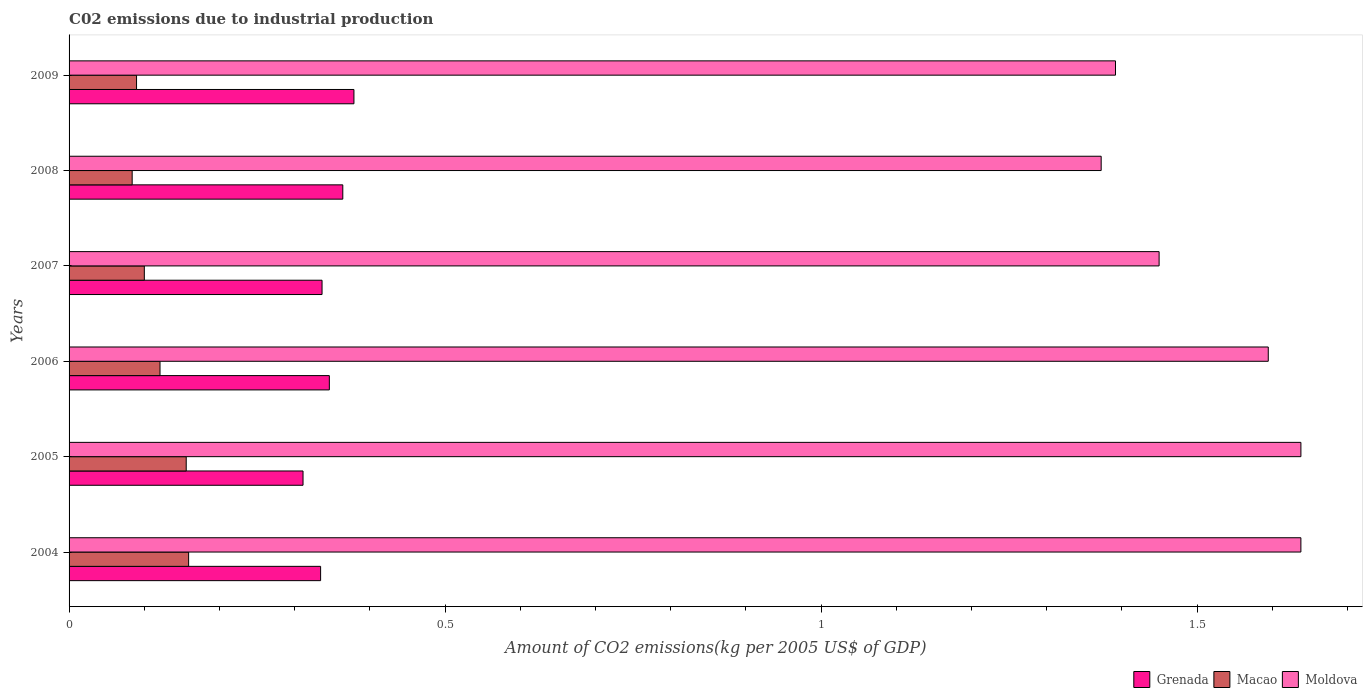How many groups of bars are there?
Your answer should be compact. 6. Are the number of bars on each tick of the Y-axis equal?
Provide a short and direct response. Yes. How many bars are there on the 5th tick from the top?
Offer a terse response. 3. How many bars are there on the 3rd tick from the bottom?
Offer a very short reply. 3. What is the label of the 4th group of bars from the top?
Provide a succinct answer. 2006. What is the amount of CO2 emitted due to industrial production in Moldova in 2005?
Keep it short and to the point. 1.64. Across all years, what is the maximum amount of CO2 emitted due to industrial production in Grenada?
Your answer should be very brief. 0.38. Across all years, what is the minimum amount of CO2 emitted due to industrial production in Macao?
Make the answer very short. 0.08. In which year was the amount of CO2 emitted due to industrial production in Moldova maximum?
Your answer should be very brief. 2005. What is the total amount of CO2 emitted due to industrial production in Grenada in the graph?
Your answer should be compact. 2.07. What is the difference between the amount of CO2 emitted due to industrial production in Moldova in 2007 and that in 2009?
Provide a short and direct response. 0.06. What is the difference between the amount of CO2 emitted due to industrial production in Macao in 2006 and the amount of CO2 emitted due to industrial production in Grenada in 2007?
Your answer should be very brief. -0.22. What is the average amount of CO2 emitted due to industrial production in Macao per year?
Provide a succinct answer. 0.12. In the year 2007, what is the difference between the amount of CO2 emitted due to industrial production in Macao and amount of CO2 emitted due to industrial production in Grenada?
Offer a very short reply. -0.24. What is the ratio of the amount of CO2 emitted due to industrial production in Macao in 2005 to that in 2007?
Your answer should be compact. 1.56. Is the difference between the amount of CO2 emitted due to industrial production in Macao in 2007 and 2009 greater than the difference between the amount of CO2 emitted due to industrial production in Grenada in 2007 and 2009?
Your answer should be very brief. Yes. What is the difference between the highest and the second highest amount of CO2 emitted due to industrial production in Macao?
Make the answer very short. 0. What is the difference between the highest and the lowest amount of CO2 emitted due to industrial production in Macao?
Offer a terse response. 0.08. What does the 3rd bar from the top in 2009 represents?
Your response must be concise. Grenada. What does the 3rd bar from the bottom in 2004 represents?
Make the answer very short. Moldova. How many bars are there?
Make the answer very short. 18. Are all the bars in the graph horizontal?
Keep it short and to the point. Yes. How many years are there in the graph?
Your answer should be compact. 6. Are the values on the major ticks of X-axis written in scientific E-notation?
Your answer should be very brief. No. Does the graph contain any zero values?
Ensure brevity in your answer.  No. Does the graph contain grids?
Your answer should be very brief. No. How many legend labels are there?
Give a very brief answer. 3. What is the title of the graph?
Keep it short and to the point. C02 emissions due to industrial production. What is the label or title of the X-axis?
Your answer should be very brief. Amount of CO2 emissions(kg per 2005 US$ of GDP). What is the label or title of the Y-axis?
Offer a terse response. Years. What is the Amount of CO2 emissions(kg per 2005 US$ of GDP) of Grenada in 2004?
Provide a short and direct response. 0.33. What is the Amount of CO2 emissions(kg per 2005 US$ of GDP) of Macao in 2004?
Give a very brief answer. 0.16. What is the Amount of CO2 emissions(kg per 2005 US$ of GDP) in Moldova in 2004?
Ensure brevity in your answer.  1.64. What is the Amount of CO2 emissions(kg per 2005 US$ of GDP) of Grenada in 2005?
Provide a short and direct response. 0.31. What is the Amount of CO2 emissions(kg per 2005 US$ of GDP) of Macao in 2005?
Provide a succinct answer. 0.16. What is the Amount of CO2 emissions(kg per 2005 US$ of GDP) of Moldova in 2005?
Make the answer very short. 1.64. What is the Amount of CO2 emissions(kg per 2005 US$ of GDP) of Grenada in 2006?
Offer a very short reply. 0.35. What is the Amount of CO2 emissions(kg per 2005 US$ of GDP) in Macao in 2006?
Provide a short and direct response. 0.12. What is the Amount of CO2 emissions(kg per 2005 US$ of GDP) of Moldova in 2006?
Your answer should be very brief. 1.59. What is the Amount of CO2 emissions(kg per 2005 US$ of GDP) of Grenada in 2007?
Provide a succinct answer. 0.34. What is the Amount of CO2 emissions(kg per 2005 US$ of GDP) in Macao in 2007?
Offer a very short reply. 0.1. What is the Amount of CO2 emissions(kg per 2005 US$ of GDP) in Moldova in 2007?
Offer a terse response. 1.45. What is the Amount of CO2 emissions(kg per 2005 US$ of GDP) of Grenada in 2008?
Your answer should be compact. 0.36. What is the Amount of CO2 emissions(kg per 2005 US$ of GDP) of Macao in 2008?
Offer a terse response. 0.08. What is the Amount of CO2 emissions(kg per 2005 US$ of GDP) of Moldova in 2008?
Provide a short and direct response. 1.37. What is the Amount of CO2 emissions(kg per 2005 US$ of GDP) in Grenada in 2009?
Provide a short and direct response. 0.38. What is the Amount of CO2 emissions(kg per 2005 US$ of GDP) of Macao in 2009?
Keep it short and to the point. 0.09. What is the Amount of CO2 emissions(kg per 2005 US$ of GDP) of Moldova in 2009?
Ensure brevity in your answer.  1.39. Across all years, what is the maximum Amount of CO2 emissions(kg per 2005 US$ of GDP) of Grenada?
Your response must be concise. 0.38. Across all years, what is the maximum Amount of CO2 emissions(kg per 2005 US$ of GDP) in Macao?
Offer a very short reply. 0.16. Across all years, what is the maximum Amount of CO2 emissions(kg per 2005 US$ of GDP) of Moldova?
Make the answer very short. 1.64. Across all years, what is the minimum Amount of CO2 emissions(kg per 2005 US$ of GDP) in Grenada?
Give a very brief answer. 0.31. Across all years, what is the minimum Amount of CO2 emissions(kg per 2005 US$ of GDP) of Macao?
Give a very brief answer. 0.08. Across all years, what is the minimum Amount of CO2 emissions(kg per 2005 US$ of GDP) in Moldova?
Give a very brief answer. 1.37. What is the total Amount of CO2 emissions(kg per 2005 US$ of GDP) of Grenada in the graph?
Offer a terse response. 2.07. What is the total Amount of CO2 emissions(kg per 2005 US$ of GDP) in Macao in the graph?
Give a very brief answer. 0.71. What is the total Amount of CO2 emissions(kg per 2005 US$ of GDP) of Moldova in the graph?
Your response must be concise. 9.09. What is the difference between the Amount of CO2 emissions(kg per 2005 US$ of GDP) in Grenada in 2004 and that in 2005?
Your response must be concise. 0.02. What is the difference between the Amount of CO2 emissions(kg per 2005 US$ of GDP) of Macao in 2004 and that in 2005?
Your answer should be compact. 0. What is the difference between the Amount of CO2 emissions(kg per 2005 US$ of GDP) of Grenada in 2004 and that in 2006?
Provide a short and direct response. -0.01. What is the difference between the Amount of CO2 emissions(kg per 2005 US$ of GDP) in Macao in 2004 and that in 2006?
Your answer should be compact. 0.04. What is the difference between the Amount of CO2 emissions(kg per 2005 US$ of GDP) in Moldova in 2004 and that in 2006?
Your answer should be compact. 0.04. What is the difference between the Amount of CO2 emissions(kg per 2005 US$ of GDP) of Grenada in 2004 and that in 2007?
Provide a succinct answer. -0. What is the difference between the Amount of CO2 emissions(kg per 2005 US$ of GDP) in Macao in 2004 and that in 2007?
Give a very brief answer. 0.06. What is the difference between the Amount of CO2 emissions(kg per 2005 US$ of GDP) in Moldova in 2004 and that in 2007?
Your answer should be compact. 0.19. What is the difference between the Amount of CO2 emissions(kg per 2005 US$ of GDP) in Grenada in 2004 and that in 2008?
Give a very brief answer. -0.03. What is the difference between the Amount of CO2 emissions(kg per 2005 US$ of GDP) in Macao in 2004 and that in 2008?
Ensure brevity in your answer.  0.08. What is the difference between the Amount of CO2 emissions(kg per 2005 US$ of GDP) of Moldova in 2004 and that in 2008?
Offer a terse response. 0.27. What is the difference between the Amount of CO2 emissions(kg per 2005 US$ of GDP) in Grenada in 2004 and that in 2009?
Provide a short and direct response. -0.04. What is the difference between the Amount of CO2 emissions(kg per 2005 US$ of GDP) of Macao in 2004 and that in 2009?
Offer a terse response. 0.07. What is the difference between the Amount of CO2 emissions(kg per 2005 US$ of GDP) of Moldova in 2004 and that in 2009?
Give a very brief answer. 0.25. What is the difference between the Amount of CO2 emissions(kg per 2005 US$ of GDP) in Grenada in 2005 and that in 2006?
Your answer should be compact. -0.04. What is the difference between the Amount of CO2 emissions(kg per 2005 US$ of GDP) in Macao in 2005 and that in 2006?
Provide a succinct answer. 0.03. What is the difference between the Amount of CO2 emissions(kg per 2005 US$ of GDP) of Moldova in 2005 and that in 2006?
Your response must be concise. 0.04. What is the difference between the Amount of CO2 emissions(kg per 2005 US$ of GDP) in Grenada in 2005 and that in 2007?
Ensure brevity in your answer.  -0.03. What is the difference between the Amount of CO2 emissions(kg per 2005 US$ of GDP) of Macao in 2005 and that in 2007?
Your response must be concise. 0.06. What is the difference between the Amount of CO2 emissions(kg per 2005 US$ of GDP) of Moldova in 2005 and that in 2007?
Keep it short and to the point. 0.19. What is the difference between the Amount of CO2 emissions(kg per 2005 US$ of GDP) of Grenada in 2005 and that in 2008?
Provide a short and direct response. -0.05. What is the difference between the Amount of CO2 emissions(kg per 2005 US$ of GDP) in Macao in 2005 and that in 2008?
Provide a short and direct response. 0.07. What is the difference between the Amount of CO2 emissions(kg per 2005 US$ of GDP) of Moldova in 2005 and that in 2008?
Offer a very short reply. 0.27. What is the difference between the Amount of CO2 emissions(kg per 2005 US$ of GDP) of Grenada in 2005 and that in 2009?
Give a very brief answer. -0.07. What is the difference between the Amount of CO2 emissions(kg per 2005 US$ of GDP) in Macao in 2005 and that in 2009?
Keep it short and to the point. 0.07. What is the difference between the Amount of CO2 emissions(kg per 2005 US$ of GDP) of Moldova in 2005 and that in 2009?
Make the answer very short. 0.25. What is the difference between the Amount of CO2 emissions(kg per 2005 US$ of GDP) of Grenada in 2006 and that in 2007?
Give a very brief answer. 0.01. What is the difference between the Amount of CO2 emissions(kg per 2005 US$ of GDP) in Macao in 2006 and that in 2007?
Provide a succinct answer. 0.02. What is the difference between the Amount of CO2 emissions(kg per 2005 US$ of GDP) of Moldova in 2006 and that in 2007?
Ensure brevity in your answer.  0.15. What is the difference between the Amount of CO2 emissions(kg per 2005 US$ of GDP) of Grenada in 2006 and that in 2008?
Keep it short and to the point. -0.02. What is the difference between the Amount of CO2 emissions(kg per 2005 US$ of GDP) in Macao in 2006 and that in 2008?
Ensure brevity in your answer.  0.04. What is the difference between the Amount of CO2 emissions(kg per 2005 US$ of GDP) of Moldova in 2006 and that in 2008?
Give a very brief answer. 0.22. What is the difference between the Amount of CO2 emissions(kg per 2005 US$ of GDP) of Grenada in 2006 and that in 2009?
Make the answer very short. -0.03. What is the difference between the Amount of CO2 emissions(kg per 2005 US$ of GDP) in Macao in 2006 and that in 2009?
Keep it short and to the point. 0.03. What is the difference between the Amount of CO2 emissions(kg per 2005 US$ of GDP) of Moldova in 2006 and that in 2009?
Keep it short and to the point. 0.2. What is the difference between the Amount of CO2 emissions(kg per 2005 US$ of GDP) in Grenada in 2007 and that in 2008?
Offer a terse response. -0.03. What is the difference between the Amount of CO2 emissions(kg per 2005 US$ of GDP) in Macao in 2007 and that in 2008?
Your response must be concise. 0.02. What is the difference between the Amount of CO2 emissions(kg per 2005 US$ of GDP) of Moldova in 2007 and that in 2008?
Offer a very short reply. 0.08. What is the difference between the Amount of CO2 emissions(kg per 2005 US$ of GDP) in Grenada in 2007 and that in 2009?
Your answer should be compact. -0.04. What is the difference between the Amount of CO2 emissions(kg per 2005 US$ of GDP) in Macao in 2007 and that in 2009?
Your answer should be compact. 0.01. What is the difference between the Amount of CO2 emissions(kg per 2005 US$ of GDP) in Moldova in 2007 and that in 2009?
Your answer should be compact. 0.06. What is the difference between the Amount of CO2 emissions(kg per 2005 US$ of GDP) in Grenada in 2008 and that in 2009?
Offer a very short reply. -0.01. What is the difference between the Amount of CO2 emissions(kg per 2005 US$ of GDP) in Macao in 2008 and that in 2009?
Keep it short and to the point. -0.01. What is the difference between the Amount of CO2 emissions(kg per 2005 US$ of GDP) in Moldova in 2008 and that in 2009?
Offer a terse response. -0.02. What is the difference between the Amount of CO2 emissions(kg per 2005 US$ of GDP) of Grenada in 2004 and the Amount of CO2 emissions(kg per 2005 US$ of GDP) of Macao in 2005?
Your answer should be compact. 0.18. What is the difference between the Amount of CO2 emissions(kg per 2005 US$ of GDP) in Grenada in 2004 and the Amount of CO2 emissions(kg per 2005 US$ of GDP) in Moldova in 2005?
Your answer should be very brief. -1.3. What is the difference between the Amount of CO2 emissions(kg per 2005 US$ of GDP) of Macao in 2004 and the Amount of CO2 emissions(kg per 2005 US$ of GDP) of Moldova in 2005?
Keep it short and to the point. -1.48. What is the difference between the Amount of CO2 emissions(kg per 2005 US$ of GDP) in Grenada in 2004 and the Amount of CO2 emissions(kg per 2005 US$ of GDP) in Macao in 2006?
Your response must be concise. 0.21. What is the difference between the Amount of CO2 emissions(kg per 2005 US$ of GDP) of Grenada in 2004 and the Amount of CO2 emissions(kg per 2005 US$ of GDP) of Moldova in 2006?
Your answer should be very brief. -1.26. What is the difference between the Amount of CO2 emissions(kg per 2005 US$ of GDP) in Macao in 2004 and the Amount of CO2 emissions(kg per 2005 US$ of GDP) in Moldova in 2006?
Give a very brief answer. -1.44. What is the difference between the Amount of CO2 emissions(kg per 2005 US$ of GDP) of Grenada in 2004 and the Amount of CO2 emissions(kg per 2005 US$ of GDP) of Macao in 2007?
Your answer should be very brief. 0.23. What is the difference between the Amount of CO2 emissions(kg per 2005 US$ of GDP) in Grenada in 2004 and the Amount of CO2 emissions(kg per 2005 US$ of GDP) in Moldova in 2007?
Provide a succinct answer. -1.12. What is the difference between the Amount of CO2 emissions(kg per 2005 US$ of GDP) in Macao in 2004 and the Amount of CO2 emissions(kg per 2005 US$ of GDP) in Moldova in 2007?
Your response must be concise. -1.29. What is the difference between the Amount of CO2 emissions(kg per 2005 US$ of GDP) of Grenada in 2004 and the Amount of CO2 emissions(kg per 2005 US$ of GDP) of Macao in 2008?
Your response must be concise. 0.25. What is the difference between the Amount of CO2 emissions(kg per 2005 US$ of GDP) of Grenada in 2004 and the Amount of CO2 emissions(kg per 2005 US$ of GDP) of Moldova in 2008?
Give a very brief answer. -1.04. What is the difference between the Amount of CO2 emissions(kg per 2005 US$ of GDP) of Macao in 2004 and the Amount of CO2 emissions(kg per 2005 US$ of GDP) of Moldova in 2008?
Provide a succinct answer. -1.21. What is the difference between the Amount of CO2 emissions(kg per 2005 US$ of GDP) in Grenada in 2004 and the Amount of CO2 emissions(kg per 2005 US$ of GDP) in Macao in 2009?
Provide a short and direct response. 0.24. What is the difference between the Amount of CO2 emissions(kg per 2005 US$ of GDP) in Grenada in 2004 and the Amount of CO2 emissions(kg per 2005 US$ of GDP) in Moldova in 2009?
Ensure brevity in your answer.  -1.06. What is the difference between the Amount of CO2 emissions(kg per 2005 US$ of GDP) in Macao in 2004 and the Amount of CO2 emissions(kg per 2005 US$ of GDP) in Moldova in 2009?
Provide a succinct answer. -1.23. What is the difference between the Amount of CO2 emissions(kg per 2005 US$ of GDP) of Grenada in 2005 and the Amount of CO2 emissions(kg per 2005 US$ of GDP) of Macao in 2006?
Give a very brief answer. 0.19. What is the difference between the Amount of CO2 emissions(kg per 2005 US$ of GDP) of Grenada in 2005 and the Amount of CO2 emissions(kg per 2005 US$ of GDP) of Moldova in 2006?
Offer a very short reply. -1.28. What is the difference between the Amount of CO2 emissions(kg per 2005 US$ of GDP) of Macao in 2005 and the Amount of CO2 emissions(kg per 2005 US$ of GDP) of Moldova in 2006?
Make the answer very short. -1.44. What is the difference between the Amount of CO2 emissions(kg per 2005 US$ of GDP) of Grenada in 2005 and the Amount of CO2 emissions(kg per 2005 US$ of GDP) of Macao in 2007?
Make the answer very short. 0.21. What is the difference between the Amount of CO2 emissions(kg per 2005 US$ of GDP) of Grenada in 2005 and the Amount of CO2 emissions(kg per 2005 US$ of GDP) of Moldova in 2007?
Give a very brief answer. -1.14. What is the difference between the Amount of CO2 emissions(kg per 2005 US$ of GDP) in Macao in 2005 and the Amount of CO2 emissions(kg per 2005 US$ of GDP) in Moldova in 2007?
Make the answer very short. -1.29. What is the difference between the Amount of CO2 emissions(kg per 2005 US$ of GDP) of Grenada in 2005 and the Amount of CO2 emissions(kg per 2005 US$ of GDP) of Macao in 2008?
Provide a short and direct response. 0.23. What is the difference between the Amount of CO2 emissions(kg per 2005 US$ of GDP) in Grenada in 2005 and the Amount of CO2 emissions(kg per 2005 US$ of GDP) in Moldova in 2008?
Make the answer very short. -1.06. What is the difference between the Amount of CO2 emissions(kg per 2005 US$ of GDP) of Macao in 2005 and the Amount of CO2 emissions(kg per 2005 US$ of GDP) of Moldova in 2008?
Provide a short and direct response. -1.22. What is the difference between the Amount of CO2 emissions(kg per 2005 US$ of GDP) of Grenada in 2005 and the Amount of CO2 emissions(kg per 2005 US$ of GDP) of Macao in 2009?
Provide a succinct answer. 0.22. What is the difference between the Amount of CO2 emissions(kg per 2005 US$ of GDP) in Grenada in 2005 and the Amount of CO2 emissions(kg per 2005 US$ of GDP) in Moldova in 2009?
Give a very brief answer. -1.08. What is the difference between the Amount of CO2 emissions(kg per 2005 US$ of GDP) of Macao in 2005 and the Amount of CO2 emissions(kg per 2005 US$ of GDP) of Moldova in 2009?
Your answer should be very brief. -1.24. What is the difference between the Amount of CO2 emissions(kg per 2005 US$ of GDP) in Grenada in 2006 and the Amount of CO2 emissions(kg per 2005 US$ of GDP) in Macao in 2007?
Provide a succinct answer. 0.25. What is the difference between the Amount of CO2 emissions(kg per 2005 US$ of GDP) of Grenada in 2006 and the Amount of CO2 emissions(kg per 2005 US$ of GDP) of Moldova in 2007?
Your answer should be very brief. -1.1. What is the difference between the Amount of CO2 emissions(kg per 2005 US$ of GDP) in Macao in 2006 and the Amount of CO2 emissions(kg per 2005 US$ of GDP) in Moldova in 2007?
Your answer should be very brief. -1.33. What is the difference between the Amount of CO2 emissions(kg per 2005 US$ of GDP) of Grenada in 2006 and the Amount of CO2 emissions(kg per 2005 US$ of GDP) of Macao in 2008?
Provide a succinct answer. 0.26. What is the difference between the Amount of CO2 emissions(kg per 2005 US$ of GDP) of Grenada in 2006 and the Amount of CO2 emissions(kg per 2005 US$ of GDP) of Moldova in 2008?
Your response must be concise. -1.03. What is the difference between the Amount of CO2 emissions(kg per 2005 US$ of GDP) of Macao in 2006 and the Amount of CO2 emissions(kg per 2005 US$ of GDP) of Moldova in 2008?
Make the answer very short. -1.25. What is the difference between the Amount of CO2 emissions(kg per 2005 US$ of GDP) in Grenada in 2006 and the Amount of CO2 emissions(kg per 2005 US$ of GDP) in Macao in 2009?
Offer a very short reply. 0.26. What is the difference between the Amount of CO2 emissions(kg per 2005 US$ of GDP) in Grenada in 2006 and the Amount of CO2 emissions(kg per 2005 US$ of GDP) in Moldova in 2009?
Your answer should be compact. -1.05. What is the difference between the Amount of CO2 emissions(kg per 2005 US$ of GDP) of Macao in 2006 and the Amount of CO2 emissions(kg per 2005 US$ of GDP) of Moldova in 2009?
Keep it short and to the point. -1.27. What is the difference between the Amount of CO2 emissions(kg per 2005 US$ of GDP) of Grenada in 2007 and the Amount of CO2 emissions(kg per 2005 US$ of GDP) of Macao in 2008?
Provide a short and direct response. 0.25. What is the difference between the Amount of CO2 emissions(kg per 2005 US$ of GDP) in Grenada in 2007 and the Amount of CO2 emissions(kg per 2005 US$ of GDP) in Moldova in 2008?
Ensure brevity in your answer.  -1.04. What is the difference between the Amount of CO2 emissions(kg per 2005 US$ of GDP) in Macao in 2007 and the Amount of CO2 emissions(kg per 2005 US$ of GDP) in Moldova in 2008?
Offer a terse response. -1.27. What is the difference between the Amount of CO2 emissions(kg per 2005 US$ of GDP) in Grenada in 2007 and the Amount of CO2 emissions(kg per 2005 US$ of GDP) in Macao in 2009?
Offer a terse response. 0.25. What is the difference between the Amount of CO2 emissions(kg per 2005 US$ of GDP) of Grenada in 2007 and the Amount of CO2 emissions(kg per 2005 US$ of GDP) of Moldova in 2009?
Offer a very short reply. -1.06. What is the difference between the Amount of CO2 emissions(kg per 2005 US$ of GDP) of Macao in 2007 and the Amount of CO2 emissions(kg per 2005 US$ of GDP) of Moldova in 2009?
Your answer should be compact. -1.29. What is the difference between the Amount of CO2 emissions(kg per 2005 US$ of GDP) of Grenada in 2008 and the Amount of CO2 emissions(kg per 2005 US$ of GDP) of Macao in 2009?
Your answer should be very brief. 0.27. What is the difference between the Amount of CO2 emissions(kg per 2005 US$ of GDP) in Grenada in 2008 and the Amount of CO2 emissions(kg per 2005 US$ of GDP) in Moldova in 2009?
Provide a succinct answer. -1.03. What is the difference between the Amount of CO2 emissions(kg per 2005 US$ of GDP) in Macao in 2008 and the Amount of CO2 emissions(kg per 2005 US$ of GDP) in Moldova in 2009?
Give a very brief answer. -1.31. What is the average Amount of CO2 emissions(kg per 2005 US$ of GDP) in Grenada per year?
Your response must be concise. 0.35. What is the average Amount of CO2 emissions(kg per 2005 US$ of GDP) of Macao per year?
Your answer should be very brief. 0.12. What is the average Amount of CO2 emissions(kg per 2005 US$ of GDP) in Moldova per year?
Your response must be concise. 1.51. In the year 2004, what is the difference between the Amount of CO2 emissions(kg per 2005 US$ of GDP) of Grenada and Amount of CO2 emissions(kg per 2005 US$ of GDP) of Macao?
Your response must be concise. 0.18. In the year 2004, what is the difference between the Amount of CO2 emissions(kg per 2005 US$ of GDP) of Grenada and Amount of CO2 emissions(kg per 2005 US$ of GDP) of Moldova?
Offer a terse response. -1.3. In the year 2004, what is the difference between the Amount of CO2 emissions(kg per 2005 US$ of GDP) in Macao and Amount of CO2 emissions(kg per 2005 US$ of GDP) in Moldova?
Provide a succinct answer. -1.48. In the year 2005, what is the difference between the Amount of CO2 emissions(kg per 2005 US$ of GDP) of Grenada and Amount of CO2 emissions(kg per 2005 US$ of GDP) of Macao?
Provide a short and direct response. 0.16. In the year 2005, what is the difference between the Amount of CO2 emissions(kg per 2005 US$ of GDP) of Grenada and Amount of CO2 emissions(kg per 2005 US$ of GDP) of Moldova?
Offer a very short reply. -1.33. In the year 2005, what is the difference between the Amount of CO2 emissions(kg per 2005 US$ of GDP) of Macao and Amount of CO2 emissions(kg per 2005 US$ of GDP) of Moldova?
Provide a succinct answer. -1.48. In the year 2006, what is the difference between the Amount of CO2 emissions(kg per 2005 US$ of GDP) of Grenada and Amount of CO2 emissions(kg per 2005 US$ of GDP) of Macao?
Your answer should be very brief. 0.23. In the year 2006, what is the difference between the Amount of CO2 emissions(kg per 2005 US$ of GDP) of Grenada and Amount of CO2 emissions(kg per 2005 US$ of GDP) of Moldova?
Your answer should be very brief. -1.25. In the year 2006, what is the difference between the Amount of CO2 emissions(kg per 2005 US$ of GDP) of Macao and Amount of CO2 emissions(kg per 2005 US$ of GDP) of Moldova?
Offer a terse response. -1.47. In the year 2007, what is the difference between the Amount of CO2 emissions(kg per 2005 US$ of GDP) in Grenada and Amount of CO2 emissions(kg per 2005 US$ of GDP) in Macao?
Your answer should be compact. 0.24. In the year 2007, what is the difference between the Amount of CO2 emissions(kg per 2005 US$ of GDP) in Grenada and Amount of CO2 emissions(kg per 2005 US$ of GDP) in Moldova?
Provide a succinct answer. -1.11. In the year 2007, what is the difference between the Amount of CO2 emissions(kg per 2005 US$ of GDP) in Macao and Amount of CO2 emissions(kg per 2005 US$ of GDP) in Moldova?
Keep it short and to the point. -1.35. In the year 2008, what is the difference between the Amount of CO2 emissions(kg per 2005 US$ of GDP) in Grenada and Amount of CO2 emissions(kg per 2005 US$ of GDP) in Macao?
Make the answer very short. 0.28. In the year 2008, what is the difference between the Amount of CO2 emissions(kg per 2005 US$ of GDP) of Grenada and Amount of CO2 emissions(kg per 2005 US$ of GDP) of Moldova?
Ensure brevity in your answer.  -1.01. In the year 2008, what is the difference between the Amount of CO2 emissions(kg per 2005 US$ of GDP) in Macao and Amount of CO2 emissions(kg per 2005 US$ of GDP) in Moldova?
Provide a succinct answer. -1.29. In the year 2009, what is the difference between the Amount of CO2 emissions(kg per 2005 US$ of GDP) in Grenada and Amount of CO2 emissions(kg per 2005 US$ of GDP) in Macao?
Your answer should be very brief. 0.29. In the year 2009, what is the difference between the Amount of CO2 emissions(kg per 2005 US$ of GDP) in Grenada and Amount of CO2 emissions(kg per 2005 US$ of GDP) in Moldova?
Your answer should be compact. -1.01. In the year 2009, what is the difference between the Amount of CO2 emissions(kg per 2005 US$ of GDP) in Macao and Amount of CO2 emissions(kg per 2005 US$ of GDP) in Moldova?
Offer a very short reply. -1.3. What is the ratio of the Amount of CO2 emissions(kg per 2005 US$ of GDP) of Grenada in 2004 to that in 2005?
Offer a terse response. 1.08. What is the ratio of the Amount of CO2 emissions(kg per 2005 US$ of GDP) of Macao in 2004 to that in 2005?
Provide a succinct answer. 1.02. What is the ratio of the Amount of CO2 emissions(kg per 2005 US$ of GDP) of Grenada in 2004 to that in 2006?
Offer a very short reply. 0.97. What is the ratio of the Amount of CO2 emissions(kg per 2005 US$ of GDP) in Macao in 2004 to that in 2006?
Give a very brief answer. 1.31. What is the ratio of the Amount of CO2 emissions(kg per 2005 US$ of GDP) in Moldova in 2004 to that in 2006?
Offer a very short reply. 1.03. What is the ratio of the Amount of CO2 emissions(kg per 2005 US$ of GDP) of Grenada in 2004 to that in 2007?
Provide a short and direct response. 0.99. What is the ratio of the Amount of CO2 emissions(kg per 2005 US$ of GDP) of Macao in 2004 to that in 2007?
Your answer should be compact. 1.59. What is the ratio of the Amount of CO2 emissions(kg per 2005 US$ of GDP) in Moldova in 2004 to that in 2007?
Offer a terse response. 1.13. What is the ratio of the Amount of CO2 emissions(kg per 2005 US$ of GDP) in Grenada in 2004 to that in 2008?
Your answer should be compact. 0.92. What is the ratio of the Amount of CO2 emissions(kg per 2005 US$ of GDP) in Macao in 2004 to that in 2008?
Keep it short and to the point. 1.89. What is the ratio of the Amount of CO2 emissions(kg per 2005 US$ of GDP) of Moldova in 2004 to that in 2008?
Your answer should be very brief. 1.19. What is the ratio of the Amount of CO2 emissions(kg per 2005 US$ of GDP) of Grenada in 2004 to that in 2009?
Your answer should be compact. 0.88. What is the ratio of the Amount of CO2 emissions(kg per 2005 US$ of GDP) in Macao in 2004 to that in 2009?
Offer a terse response. 1.77. What is the ratio of the Amount of CO2 emissions(kg per 2005 US$ of GDP) in Moldova in 2004 to that in 2009?
Ensure brevity in your answer.  1.18. What is the ratio of the Amount of CO2 emissions(kg per 2005 US$ of GDP) in Grenada in 2005 to that in 2006?
Your answer should be compact. 0.9. What is the ratio of the Amount of CO2 emissions(kg per 2005 US$ of GDP) of Macao in 2005 to that in 2006?
Ensure brevity in your answer.  1.29. What is the ratio of the Amount of CO2 emissions(kg per 2005 US$ of GDP) in Moldova in 2005 to that in 2006?
Provide a short and direct response. 1.03. What is the ratio of the Amount of CO2 emissions(kg per 2005 US$ of GDP) in Grenada in 2005 to that in 2007?
Offer a very short reply. 0.92. What is the ratio of the Amount of CO2 emissions(kg per 2005 US$ of GDP) of Macao in 2005 to that in 2007?
Provide a short and direct response. 1.56. What is the ratio of the Amount of CO2 emissions(kg per 2005 US$ of GDP) of Moldova in 2005 to that in 2007?
Ensure brevity in your answer.  1.13. What is the ratio of the Amount of CO2 emissions(kg per 2005 US$ of GDP) of Grenada in 2005 to that in 2008?
Your response must be concise. 0.85. What is the ratio of the Amount of CO2 emissions(kg per 2005 US$ of GDP) of Macao in 2005 to that in 2008?
Provide a short and direct response. 1.86. What is the ratio of the Amount of CO2 emissions(kg per 2005 US$ of GDP) of Moldova in 2005 to that in 2008?
Make the answer very short. 1.19. What is the ratio of the Amount of CO2 emissions(kg per 2005 US$ of GDP) in Grenada in 2005 to that in 2009?
Keep it short and to the point. 0.82. What is the ratio of the Amount of CO2 emissions(kg per 2005 US$ of GDP) of Macao in 2005 to that in 2009?
Make the answer very short. 1.74. What is the ratio of the Amount of CO2 emissions(kg per 2005 US$ of GDP) of Moldova in 2005 to that in 2009?
Provide a succinct answer. 1.18. What is the ratio of the Amount of CO2 emissions(kg per 2005 US$ of GDP) of Grenada in 2006 to that in 2007?
Provide a succinct answer. 1.03. What is the ratio of the Amount of CO2 emissions(kg per 2005 US$ of GDP) in Macao in 2006 to that in 2007?
Ensure brevity in your answer.  1.21. What is the ratio of the Amount of CO2 emissions(kg per 2005 US$ of GDP) in Moldova in 2006 to that in 2007?
Your answer should be very brief. 1.1. What is the ratio of the Amount of CO2 emissions(kg per 2005 US$ of GDP) of Grenada in 2006 to that in 2008?
Your response must be concise. 0.95. What is the ratio of the Amount of CO2 emissions(kg per 2005 US$ of GDP) in Macao in 2006 to that in 2008?
Provide a short and direct response. 1.44. What is the ratio of the Amount of CO2 emissions(kg per 2005 US$ of GDP) of Moldova in 2006 to that in 2008?
Provide a short and direct response. 1.16. What is the ratio of the Amount of CO2 emissions(kg per 2005 US$ of GDP) of Grenada in 2006 to that in 2009?
Offer a very short reply. 0.91. What is the ratio of the Amount of CO2 emissions(kg per 2005 US$ of GDP) of Macao in 2006 to that in 2009?
Give a very brief answer. 1.35. What is the ratio of the Amount of CO2 emissions(kg per 2005 US$ of GDP) of Moldova in 2006 to that in 2009?
Your response must be concise. 1.15. What is the ratio of the Amount of CO2 emissions(kg per 2005 US$ of GDP) in Grenada in 2007 to that in 2008?
Provide a succinct answer. 0.92. What is the ratio of the Amount of CO2 emissions(kg per 2005 US$ of GDP) in Macao in 2007 to that in 2008?
Provide a succinct answer. 1.19. What is the ratio of the Amount of CO2 emissions(kg per 2005 US$ of GDP) in Moldova in 2007 to that in 2008?
Give a very brief answer. 1.06. What is the ratio of the Amount of CO2 emissions(kg per 2005 US$ of GDP) in Grenada in 2007 to that in 2009?
Ensure brevity in your answer.  0.89. What is the ratio of the Amount of CO2 emissions(kg per 2005 US$ of GDP) in Macao in 2007 to that in 2009?
Your response must be concise. 1.12. What is the ratio of the Amount of CO2 emissions(kg per 2005 US$ of GDP) of Moldova in 2007 to that in 2009?
Your answer should be very brief. 1.04. What is the ratio of the Amount of CO2 emissions(kg per 2005 US$ of GDP) in Grenada in 2008 to that in 2009?
Keep it short and to the point. 0.96. What is the ratio of the Amount of CO2 emissions(kg per 2005 US$ of GDP) in Macao in 2008 to that in 2009?
Make the answer very short. 0.94. What is the ratio of the Amount of CO2 emissions(kg per 2005 US$ of GDP) in Moldova in 2008 to that in 2009?
Your answer should be very brief. 0.99. What is the difference between the highest and the second highest Amount of CO2 emissions(kg per 2005 US$ of GDP) in Grenada?
Offer a terse response. 0.01. What is the difference between the highest and the second highest Amount of CO2 emissions(kg per 2005 US$ of GDP) of Macao?
Your response must be concise. 0. What is the difference between the highest and the lowest Amount of CO2 emissions(kg per 2005 US$ of GDP) in Grenada?
Offer a terse response. 0.07. What is the difference between the highest and the lowest Amount of CO2 emissions(kg per 2005 US$ of GDP) of Macao?
Offer a terse response. 0.08. What is the difference between the highest and the lowest Amount of CO2 emissions(kg per 2005 US$ of GDP) of Moldova?
Your response must be concise. 0.27. 